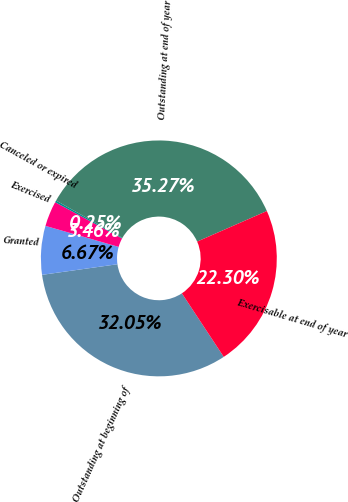Convert chart. <chart><loc_0><loc_0><loc_500><loc_500><pie_chart><fcel>Outstanding at beginning of<fcel>Granted<fcel>Exercised<fcel>Canceled or expired<fcel>Outstanding at end of year<fcel>Exercisable at end of year<nl><fcel>32.05%<fcel>6.67%<fcel>3.46%<fcel>0.25%<fcel>35.27%<fcel>22.3%<nl></chart> 